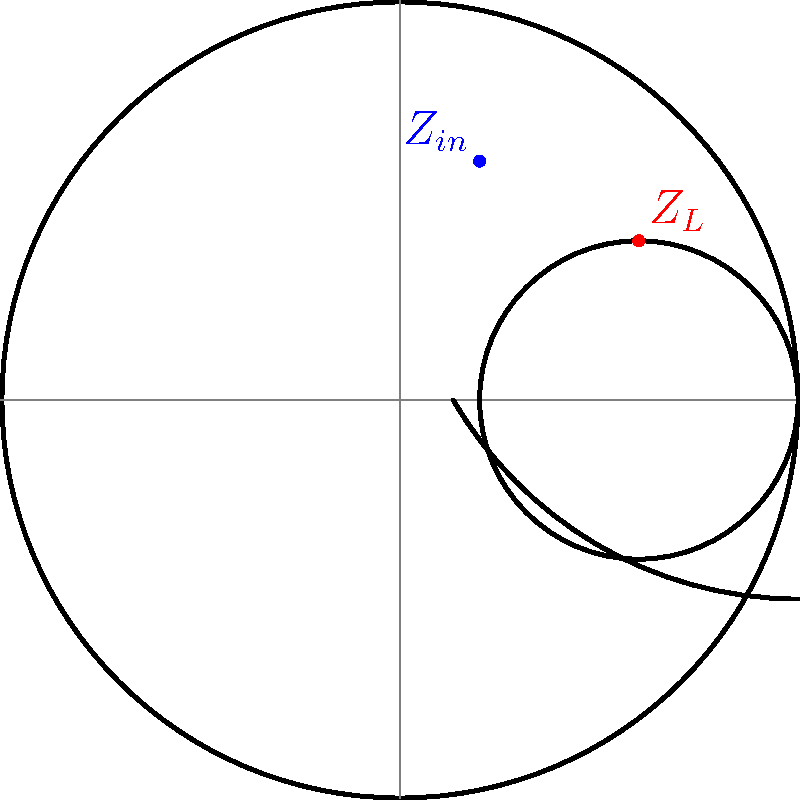Given the Smith chart shown, where $Z_L$ (red dot) represents a load impedance and $Z_{in}$ (blue dot) represents the input impedance of a matching network, determine the normalized impedance values for $Z_L$ and $Z_{in}$. What type of matching element would you add to transform $Z_L$ to $Z_{in}$? To solve this problem, we'll follow these steps:

1. Determine $Z_L$:
   - The red dot is on the intersection of a constant resistance circle and a constant reactance arc.
   - The constant resistance circle has a radius of 0.4 and is centered at (0.6, 0).
   - This corresponds to a normalized resistance of 1.5 (0.6 + 0.4 = 1, which is the 1.5 circle on a standard Smith chart).
   - The constant reactance arc intersects the real axis at about 0.4, which corresponds to a normalized reactance of +0.4.
   - Therefore, $Z_L \approx 1.5 + j0.4$

2. Determine $Z_{in}$:
   - The blue dot is located at approximately (0.2, 0.6) on the Smith chart.
   - This point is close to the 0.5 constant resistance circle and the +1 constant reactance arc.
   - Therefore, $Z_{in} \approx 0.5 + j1$

3. Determine the matching element:
   - To move from $Z_L$ to $Z_{in}$, we need to decrease the resistance and increase the reactance.
   - This can be achieved by adding a series inductor.
   - The series inductor will move the impedance point counterclockwise along a constant resistance circle, then along a constant conductance arc to reach $Z_{in}$.
Answer: $Z_L \approx 1.5 + j0.4$, $Z_{in} \approx 0.5 + j1$, series inductor 